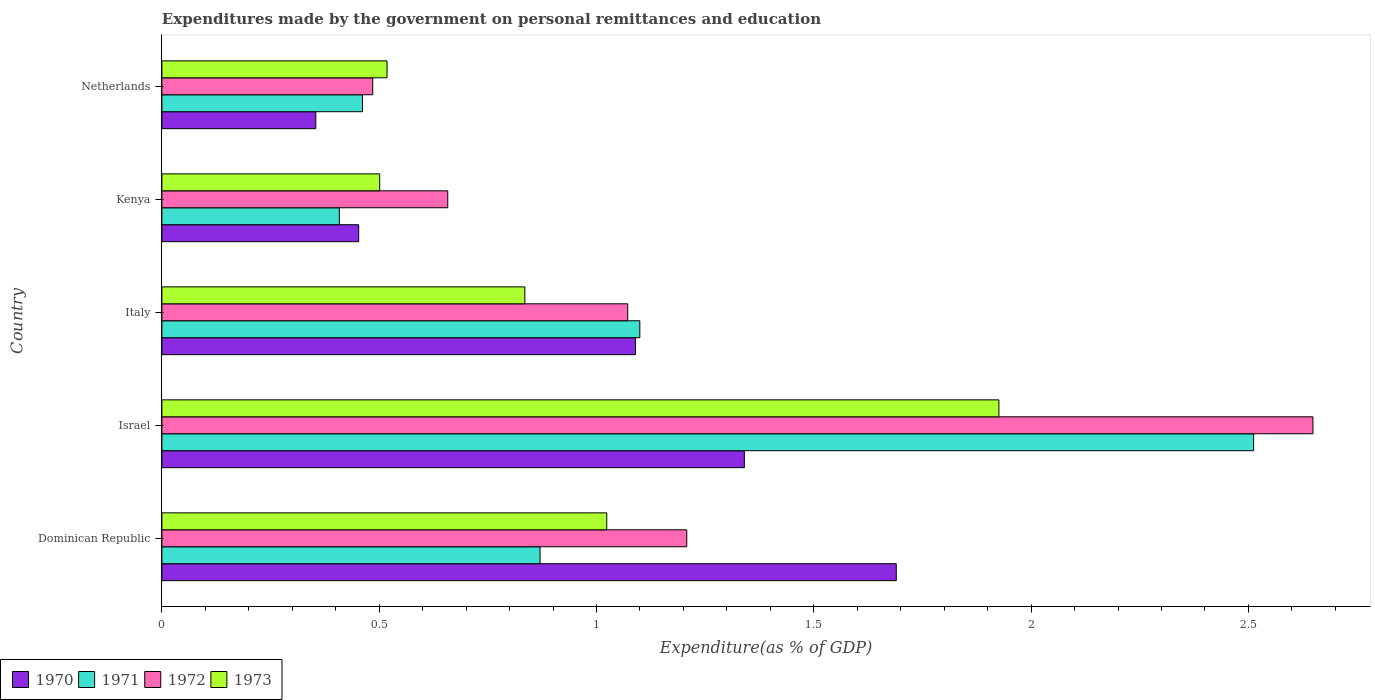How many groups of bars are there?
Give a very brief answer. 5. Are the number of bars per tick equal to the number of legend labels?
Ensure brevity in your answer.  Yes. How many bars are there on the 2nd tick from the top?
Give a very brief answer. 4. What is the label of the 5th group of bars from the top?
Ensure brevity in your answer.  Dominican Republic. What is the expenditures made by the government on personal remittances and education in 1972 in Netherlands?
Offer a very short reply. 0.49. Across all countries, what is the maximum expenditures made by the government on personal remittances and education in 1973?
Give a very brief answer. 1.93. Across all countries, what is the minimum expenditures made by the government on personal remittances and education in 1973?
Offer a very short reply. 0.5. In which country was the expenditures made by the government on personal remittances and education in 1970 maximum?
Offer a very short reply. Dominican Republic. In which country was the expenditures made by the government on personal remittances and education in 1971 minimum?
Your answer should be compact. Kenya. What is the total expenditures made by the government on personal remittances and education in 1972 in the graph?
Make the answer very short. 6.07. What is the difference between the expenditures made by the government on personal remittances and education in 1972 in Israel and that in Kenya?
Offer a terse response. 1.99. What is the difference between the expenditures made by the government on personal remittances and education in 1971 in Italy and the expenditures made by the government on personal remittances and education in 1973 in Netherlands?
Provide a short and direct response. 0.58. What is the average expenditures made by the government on personal remittances and education in 1971 per country?
Your response must be concise. 1.07. What is the difference between the expenditures made by the government on personal remittances and education in 1973 and expenditures made by the government on personal remittances and education in 1970 in Dominican Republic?
Your response must be concise. -0.67. What is the ratio of the expenditures made by the government on personal remittances and education in 1971 in Dominican Republic to that in Kenya?
Offer a terse response. 2.13. Is the difference between the expenditures made by the government on personal remittances and education in 1973 in Dominican Republic and Kenya greater than the difference between the expenditures made by the government on personal remittances and education in 1970 in Dominican Republic and Kenya?
Offer a very short reply. No. What is the difference between the highest and the second highest expenditures made by the government on personal remittances and education in 1971?
Your answer should be very brief. 1.41. What is the difference between the highest and the lowest expenditures made by the government on personal remittances and education in 1973?
Provide a succinct answer. 1.42. In how many countries, is the expenditures made by the government on personal remittances and education in 1973 greater than the average expenditures made by the government on personal remittances and education in 1973 taken over all countries?
Offer a very short reply. 2. Is it the case that in every country, the sum of the expenditures made by the government on personal remittances and education in 1970 and expenditures made by the government on personal remittances and education in 1972 is greater than the sum of expenditures made by the government on personal remittances and education in 1971 and expenditures made by the government on personal remittances and education in 1973?
Your answer should be compact. No. Is it the case that in every country, the sum of the expenditures made by the government on personal remittances and education in 1973 and expenditures made by the government on personal remittances and education in 1970 is greater than the expenditures made by the government on personal remittances and education in 1971?
Give a very brief answer. Yes. How many bars are there?
Give a very brief answer. 20. Are all the bars in the graph horizontal?
Ensure brevity in your answer.  Yes. How many countries are there in the graph?
Offer a terse response. 5. What is the difference between two consecutive major ticks on the X-axis?
Keep it short and to the point. 0.5. Does the graph contain any zero values?
Your response must be concise. No. Does the graph contain grids?
Keep it short and to the point. No. How many legend labels are there?
Ensure brevity in your answer.  4. What is the title of the graph?
Offer a terse response. Expenditures made by the government on personal remittances and education. What is the label or title of the X-axis?
Provide a short and direct response. Expenditure(as % of GDP). What is the label or title of the Y-axis?
Offer a terse response. Country. What is the Expenditure(as % of GDP) in 1970 in Dominican Republic?
Offer a very short reply. 1.69. What is the Expenditure(as % of GDP) in 1971 in Dominican Republic?
Your response must be concise. 0.87. What is the Expenditure(as % of GDP) of 1972 in Dominican Republic?
Provide a short and direct response. 1.21. What is the Expenditure(as % of GDP) in 1973 in Dominican Republic?
Offer a terse response. 1.02. What is the Expenditure(as % of GDP) of 1970 in Israel?
Offer a terse response. 1.34. What is the Expenditure(as % of GDP) of 1971 in Israel?
Make the answer very short. 2.51. What is the Expenditure(as % of GDP) of 1972 in Israel?
Give a very brief answer. 2.65. What is the Expenditure(as % of GDP) of 1973 in Israel?
Offer a very short reply. 1.93. What is the Expenditure(as % of GDP) in 1970 in Italy?
Your answer should be compact. 1.09. What is the Expenditure(as % of GDP) in 1971 in Italy?
Make the answer very short. 1.1. What is the Expenditure(as % of GDP) of 1972 in Italy?
Provide a succinct answer. 1.07. What is the Expenditure(as % of GDP) in 1973 in Italy?
Provide a succinct answer. 0.84. What is the Expenditure(as % of GDP) in 1970 in Kenya?
Provide a short and direct response. 0.45. What is the Expenditure(as % of GDP) of 1971 in Kenya?
Your response must be concise. 0.41. What is the Expenditure(as % of GDP) of 1972 in Kenya?
Keep it short and to the point. 0.66. What is the Expenditure(as % of GDP) of 1973 in Kenya?
Make the answer very short. 0.5. What is the Expenditure(as % of GDP) in 1970 in Netherlands?
Provide a short and direct response. 0.35. What is the Expenditure(as % of GDP) of 1971 in Netherlands?
Your answer should be very brief. 0.46. What is the Expenditure(as % of GDP) in 1972 in Netherlands?
Your answer should be compact. 0.49. What is the Expenditure(as % of GDP) of 1973 in Netherlands?
Provide a short and direct response. 0.52. Across all countries, what is the maximum Expenditure(as % of GDP) of 1970?
Your answer should be compact. 1.69. Across all countries, what is the maximum Expenditure(as % of GDP) of 1971?
Provide a short and direct response. 2.51. Across all countries, what is the maximum Expenditure(as % of GDP) in 1972?
Your response must be concise. 2.65. Across all countries, what is the maximum Expenditure(as % of GDP) of 1973?
Your answer should be compact. 1.93. Across all countries, what is the minimum Expenditure(as % of GDP) of 1970?
Make the answer very short. 0.35. Across all countries, what is the minimum Expenditure(as % of GDP) of 1971?
Your answer should be very brief. 0.41. Across all countries, what is the minimum Expenditure(as % of GDP) in 1972?
Make the answer very short. 0.49. Across all countries, what is the minimum Expenditure(as % of GDP) of 1973?
Offer a very short reply. 0.5. What is the total Expenditure(as % of GDP) of 1970 in the graph?
Ensure brevity in your answer.  4.93. What is the total Expenditure(as % of GDP) of 1971 in the graph?
Make the answer very short. 5.35. What is the total Expenditure(as % of GDP) in 1972 in the graph?
Your answer should be compact. 6.07. What is the total Expenditure(as % of GDP) in 1973 in the graph?
Provide a short and direct response. 4.8. What is the difference between the Expenditure(as % of GDP) in 1970 in Dominican Republic and that in Israel?
Offer a terse response. 0.35. What is the difference between the Expenditure(as % of GDP) in 1971 in Dominican Republic and that in Israel?
Ensure brevity in your answer.  -1.64. What is the difference between the Expenditure(as % of GDP) of 1972 in Dominican Republic and that in Israel?
Keep it short and to the point. -1.44. What is the difference between the Expenditure(as % of GDP) of 1973 in Dominican Republic and that in Israel?
Give a very brief answer. -0.9. What is the difference between the Expenditure(as % of GDP) of 1970 in Dominican Republic and that in Italy?
Keep it short and to the point. 0.6. What is the difference between the Expenditure(as % of GDP) of 1971 in Dominican Republic and that in Italy?
Keep it short and to the point. -0.23. What is the difference between the Expenditure(as % of GDP) of 1972 in Dominican Republic and that in Italy?
Make the answer very short. 0.14. What is the difference between the Expenditure(as % of GDP) of 1973 in Dominican Republic and that in Italy?
Offer a very short reply. 0.19. What is the difference between the Expenditure(as % of GDP) in 1970 in Dominican Republic and that in Kenya?
Keep it short and to the point. 1.24. What is the difference between the Expenditure(as % of GDP) of 1971 in Dominican Republic and that in Kenya?
Give a very brief answer. 0.46. What is the difference between the Expenditure(as % of GDP) in 1972 in Dominican Republic and that in Kenya?
Ensure brevity in your answer.  0.55. What is the difference between the Expenditure(as % of GDP) in 1973 in Dominican Republic and that in Kenya?
Give a very brief answer. 0.52. What is the difference between the Expenditure(as % of GDP) of 1970 in Dominican Republic and that in Netherlands?
Your answer should be compact. 1.34. What is the difference between the Expenditure(as % of GDP) in 1971 in Dominican Republic and that in Netherlands?
Keep it short and to the point. 0.41. What is the difference between the Expenditure(as % of GDP) of 1972 in Dominican Republic and that in Netherlands?
Keep it short and to the point. 0.72. What is the difference between the Expenditure(as % of GDP) in 1973 in Dominican Republic and that in Netherlands?
Your answer should be very brief. 0.51. What is the difference between the Expenditure(as % of GDP) of 1970 in Israel and that in Italy?
Your answer should be very brief. 0.25. What is the difference between the Expenditure(as % of GDP) in 1971 in Israel and that in Italy?
Offer a very short reply. 1.41. What is the difference between the Expenditure(as % of GDP) of 1972 in Israel and that in Italy?
Your answer should be very brief. 1.58. What is the difference between the Expenditure(as % of GDP) of 1973 in Israel and that in Italy?
Give a very brief answer. 1.09. What is the difference between the Expenditure(as % of GDP) in 1970 in Israel and that in Kenya?
Offer a very short reply. 0.89. What is the difference between the Expenditure(as % of GDP) in 1971 in Israel and that in Kenya?
Your answer should be compact. 2.1. What is the difference between the Expenditure(as % of GDP) of 1972 in Israel and that in Kenya?
Keep it short and to the point. 1.99. What is the difference between the Expenditure(as % of GDP) of 1973 in Israel and that in Kenya?
Keep it short and to the point. 1.42. What is the difference between the Expenditure(as % of GDP) of 1970 in Israel and that in Netherlands?
Provide a short and direct response. 0.99. What is the difference between the Expenditure(as % of GDP) in 1971 in Israel and that in Netherlands?
Provide a succinct answer. 2.05. What is the difference between the Expenditure(as % of GDP) of 1972 in Israel and that in Netherlands?
Your response must be concise. 2.16. What is the difference between the Expenditure(as % of GDP) of 1973 in Israel and that in Netherlands?
Make the answer very short. 1.41. What is the difference between the Expenditure(as % of GDP) in 1970 in Italy and that in Kenya?
Offer a very short reply. 0.64. What is the difference between the Expenditure(as % of GDP) in 1971 in Italy and that in Kenya?
Keep it short and to the point. 0.69. What is the difference between the Expenditure(as % of GDP) in 1972 in Italy and that in Kenya?
Ensure brevity in your answer.  0.41. What is the difference between the Expenditure(as % of GDP) in 1973 in Italy and that in Kenya?
Offer a very short reply. 0.33. What is the difference between the Expenditure(as % of GDP) of 1970 in Italy and that in Netherlands?
Offer a terse response. 0.74. What is the difference between the Expenditure(as % of GDP) in 1971 in Italy and that in Netherlands?
Provide a succinct answer. 0.64. What is the difference between the Expenditure(as % of GDP) of 1972 in Italy and that in Netherlands?
Keep it short and to the point. 0.59. What is the difference between the Expenditure(as % of GDP) in 1973 in Italy and that in Netherlands?
Offer a terse response. 0.32. What is the difference between the Expenditure(as % of GDP) of 1970 in Kenya and that in Netherlands?
Make the answer very short. 0.1. What is the difference between the Expenditure(as % of GDP) of 1971 in Kenya and that in Netherlands?
Your response must be concise. -0.05. What is the difference between the Expenditure(as % of GDP) of 1972 in Kenya and that in Netherlands?
Make the answer very short. 0.17. What is the difference between the Expenditure(as % of GDP) of 1973 in Kenya and that in Netherlands?
Ensure brevity in your answer.  -0.02. What is the difference between the Expenditure(as % of GDP) of 1970 in Dominican Republic and the Expenditure(as % of GDP) of 1971 in Israel?
Your response must be concise. -0.82. What is the difference between the Expenditure(as % of GDP) of 1970 in Dominican Republic and the Expenditure(as % of GDP) of 1972 in Israel?
Offer a very short reply. -0.96. What is the difference between the Expenditure(as % of GDP) of 1970 in Dominican Republic and the Expenditure(as % of GDP) of 1973 in Israel?
Provide a succinct answer. -0.24. What is the difference between the Expenditure(as % of GDP) of 1971 in Dominican Republic and the Expenditure(as % of GDP) of 1972 in Israel?
Provide a short and direct response. -1.78. What is the difference between the Expenditure(as % of GDP) of 1971 in Dominican Republic and the Expenditure(as % of GDP) of 1973 in Israel?
Your answer should be compact. -1.06. What is the difference between the Expenditure(as % of GDP) of 1972 in Dominican Republic and the Expenditure(as % of GDP) of 1973 in Israel?
Offer a terse response. -0.72. What is the difference between the Expenditure(as % of GDP) in 1970 in Dominican Republic and the Expenditure(as % of GDP) in 1971 in Italy?
Your answer should be compact. 0.59. What is the difference between the Expenditure(as % of GDP) of 1970 in Dominican Republic and the Expenditure(as % of GDP) of 1972 in Italy?
Make the answer very short. 0.62. What is the difference between the Expenditure(as % of GDP) of 1970 in Dominican Republic and the Expenditure(as % of GDP) of 1973 in Italy?
Offer a terse response. 0.85. What is the difference between the Expenditure(as % of GDP) in 1971 in Dominican Republic and the Expenditure(as % of GDP) in 1972 in Italy?
Provide a short and direct response. -0.2. What is the difference between the Expenditure(as % of GDP) in 1971 in Dominican Republic and the Expenditure(as % of GDP) in 1973 in Italy?
Your response must be concise. 0.04. What is the difference between the Expenditure(as % of GDP) in 1972 in Dominican Republic and the Expenditure(as % of GDP) in 1973 in Italy?
Ensure brevity in your answer.  0.37. What is the difference between the Expenditure(as % of GDP) of 1970 in Dominican Republic and the Expenditure(as % of GDP) of 1971 in Kenya?
Offer a terse response. 1.28. What is the difference between the Expenditure(as % of GDP) of 1970 in Dominican Republic and the Expenditure(as % of GDP) of 1972 in Kenya?
Make the answer very short. 1.03. What is the difference between the Expenditure(as % of GDP) of 1970 in Dominican Republic and the Expenditure(as % of GDP) of 1973 in Kenya?
Provide a short and direct response. 1.19. What is the difference between the Expenditure(as % of GDP) of 1971 in Dominican Republic and the Expenditure(as % of GDP) of 1972 in Kenya?
Make the answer very short. 0.21. What is the difference between the Expenditure(as % of GDP) of 1971 in Dominican Republic and the Expenditure(as % of GDP) of 1973 in Kenya?
Provide a short and direct response. 0.37. What is the difference between the Expenditure(as % of GDP) of 1972 in Dominican Republic and the Expenditure(as % of GDP) of 1973 in Kenya?
Provide a short and direct response. 0.71. What is the difference between the Expenditure(as % of GDP) in 1970 in Dominican Republic and the Expenditure(as % of GDP) in 1971 in Netherlands?
Provide a succinct answer. 1.23. What is the difference between the Expenditure(as % of GDP) in 1970 in Dominican Republic and the Expenditure(as % of GDP) in 1972 in Netherlands?
Make the answer very short. 1.2. What is the difference between the Expenditure(as % of GDP) in 1970 in Dominican Republic and the Expenditure(as % of GDP) in 1973 in Netherlands?
Your answer should be compact. 1.17. What is the difference between the Expenditure(as % of GDP) in 1971 in Dominican Republic and the Expenditure(as % of GDP) in 1972 in Netherlands?
Make the answer very short. 0.39. What is the difference between the Expenditure(as % of GDP) of 1971 in Dominican Republic and the Expenditure(as % of GDP) of 1973 in Netherlands?
Your answer should be very brief. 0.35. What is the difference between the Expenditure(as % of GDP) of 1972 in Dominican Republic and the Expenditure(as % of GDP) of 1973 in Netherlands?
Your response must be concise. 0.69. What is the difference between the Expenditure(as % of GDP) in 1970 in Israel and the Expenditure(as % of GDP) in 1971 in Italy?
Your answer should be compact. 0.24. What is the difference between the Expenditure(as % of GDP) of 1970 in Israel and the Expenditure(as % of GDP) of 1972 in Italy?
Ensure brevity in your answer.  0.27. What is the difference between the Expenditure(as % of GDP) of 1970 in Israel and the Expenditure(as % of GDP) of 1973 in Italy?
Offer a terse response. 0.51. What is the difference between the Expenditure(as % of GDP) in 1971 in Israel and the Expenditure(as % of GDP) in 1972 in Italy?
Your answer should be compact. 1.44. What is the difference between the Expenditure(as % of GDP) of 1971 in Israel and the Expenditure(as % of GDP) of 1973 in Italy?
Make the answer very short. 1.68. What is the difference between the Expenditure(as % of GDP) in 1972 in Israel and the Expenditure(as % of GDP) in 1973 in Italy?
Your answer should be compact. 1.81. What is the difference between the Expenditure(as % of GDP) of 1970 in Israel and the Expenditure(as % of GDP) of 1971 in Kenya?
Make the answer very short. 0.93. What is the difference between the Expenditure(as % of GDP) in 1970 in Israel and the Expenditure(as % of GDP) in 1972 in Kenya?
Offer a terse response. 0.68. What is the difference between the Expenditure(as % of GDP) in 1970 in Israel and the Expenditure(as % of GDP) in 1973 in Kenya?
Your answer should be compact. 0.84. What is the difference between the Expenditure(as % of GDP) of 1971 in Israel and the Expenditure(as % of GDP) of 1972 in Kenya?
Your answer should be very brief. 1.85. What is the difference between the Expenditure(as % of GDP) in 1971 in Israel and the Expenditure(as % of GDP) in 1973 in Kenya?
Your response must be concise. 2.01. What is the difference between the Expenditure(as % of GDP) of 1972 in Israel and the Expenditure(as % of GDP) of 1973 in Kenya?
Your answer should be compact. 2.15. What is the difference between the Expenditure(as % of GDP) of 1970 in Israel and the Expenditure(as % of GDP) of 1971 in Netherlands?
Ensure brevity in your answer.  0.88. What is the difference between the Expenditure(as % of GDP) in 1970 in Israel and the Expenditure(as % of GDP) in 1972 in Netherlands?
Your answer should be compact. 0.85. What is the difference between the Expenditure(as % of GDP) in 1970 in Israel and the Expenditure(as % of GDP) in 1973 in Netherlands?
Ensure brevity in your answer.  0.82. What is the difference between the Expenditure(as % of GDP) of 1971 in Israel and the Expenditure(as % of GDP) of 1972 in Netherlands?
Ensure brevity in your answer.  2.03. What is the difference between the Expenditure(as % of GDP) in 1971 in Israel and the Expenditure(as % of GDP) in 1973 in Netherlands?
Make the answer very short. 1.99. What is the difference between the Expenditure(as % of GDP) in 1972 in Israel and the Expenditure(as % of GDP) in 1973 in Netherlands?
Your answer should be very brief. 2.13. What is the difference between the Expenditure(as % of GDP) of 1970 in Italy and the Expenditure(as % of GDP) of 1971 in Kenya?
Offer a terse response. 0.68. What is the difference between the Expenditure(as % of GDP) of 1970 in Italy and the Expenditure(as % of GDP) of 1972 in Kenya?
Offer a terse response. 0.43. What is the difference between the Expenditure(as % of GDP) of 1970 in Italy and the Expenditure(as % of GDP) of 1973 in Kenya?
Provide a short and direct response. 0.59. What is the difference between the Expenditure(as % of GDP) of 1971 in Italy and the Expenditure(as % of GDP) of 1972 in Kenya?
Offer a very short reply. 0.44. What is the difference between the Expenditure(as % of GDP) of 1971 in Italy and the Expenditure(as % of GDP) of 1973 in Kenya?
Provide a succinct answer. 0.6. What is the difference between the Expenditure(as % of GDP) of 1972 in Italy and the Expenditure(as % of GDP) of 1973 in Kenya?
Offer a terse response. 0.57. What is the difference between the Expenditure(as % of GDP) of 1970 in Italy and the Expenditure(as % of GDP) of 1971 in Netherlands?
Provide a succinct answer. 0.63. What is the difference between the Expenditure(as % of GDP) of 1970 in Italy and the Expenditure(as % of GDP) of 1972 in Netherlands?
Make the answer very short. 0.6. What is the difference between the Expenditure(as % of GDP) in 1970 in Italy and the Expenditure(as % of GDP) in 1973 in Netherlands?
Your response must be concise. 0.57. What is the difference between the Expenditure(as % of GDP) of 1971 in Italy and the Expenditure(as % of GDP) of 1972 in Netherlands?
Provide a short and direct response. 0.61. What is the difference between the Expenditure(as % of GDP) of 1971 in Italy and the Expenditure(as % of GDP) of 1973 in Netherlands?
Make the answer very short. 0.58. What is the difference between the Expenditure(as % of GDP) in 1972 in Italy and the Expenditure(as % of GDP) in 1973 in Netherlands?
Provide a short and direct response. 0.55. What is the difference between the Expenditure(as % of GDP) of 1970 in Kenya and the Expenditure(as % of GDP) of 1971 in Netherlands?
Offer a very short reply. -0.01. What is the difference between the Expenditure(as % of GDP) of 1970 in Kenya and the Expenditure(as % of GDP) of 1972 in Netherlands?
Provide a succinct answer. -0.03. What is the difference between the Expenditure(as % of GDP) of 1970 in Kenya and the Expenditure(as % of GDP) of 1973 in Netherlands?
Your answer should be compact. -0.07. What is the difference between the Expenditure(as % of GDP) of 1971 in Kenya and the Expenditure(as % of GDP) of 1972 in Netherlands?
Offer a very short reply. -0.08. What is the difference between the Expenditure(as % of GDP) in 1971 in Kenya and the Expenditure(as % of GDP) in 1973 in Netherlands?
Your answer should be compact. -0.11. What is the difference between the Expenditure(as % of GDP) of 1972 in Kenya and the Expenditure(as % of GDP) of 1973 in Netherlands?
Give a very brief answer. 0.14. What is the average Expenditure(as % of GDP) of 1970 per country?
Your response must be concise. 0.99. What is the average Expenditure(as % of GDP) in 1971 per country?
Keep it short and to the point. 1.07. What is the average Expenditure(as % of GDP) of 1972 per country?
Provide a short and direct response. 1.21. What is the average Expenditure(as % of GDP) in 1973 per country?
Ensure brevity in your answer.  0.96. What is the difference between the Expenditure(as % of GDP) in 1970 and Expenditure(as % of GDP) in 1971 in Dominican Republic?
Your response must be concise. 0.82. What is the difference between the Expenditure(as % of GDP) in 1970 and Expenditure(as % of GDP) in 1972 in Dominican Republic?
Give a very brief answer. 0.48. What is the difference between the Expenditure(as % of GDP) of 1970 and Expenditure(as % of GDP) of 1973 in Dominican Republic?
Make the answer very short. 0.67. What is the difference between the Expenditure(as % of GDP) in 1971 and Expenditure(as % of GDP) in 1972 in Dominican Republic?
Your answer should be very brief. -0.34. What is the difference between the Expenditure(as % of GDP) of 1971 and Expenditure(as % of GDP) of 1973 in Dominican Republic?
Keep it short and to the point. -0.15. What is the difference between the Expenditure(as % of GDP) of 1972 and Expenditure(as % of GDP) of 1973 in Dominican Republic?
Provide a short and direct response. 0.18. What is the difference between the Expenditure(as % of GDP) in 1970 and Expenditure(as % of GDP) in 1971 in Israel?
Keep it short and to the point. -1.17. What is the difference between the Expenditure(as % of GDP) of 1970 and Expenditure(as % of GDP) of 1972 in Israel?
Your response must be concise. -1.31. What is the difference between the Expenditure(as % of GDP) in 1970 and Expenditure(as % of GDP) in 1973 in Israel?
Ensure brevity in your answer.  -0.59. What is the difference between the Expenditure(as % of GDP) of 1971 and Expenditure(as % of GDP) of 1972 in Israel?
Make the answer very short. -0.14. What is the difference between the Expenditure(as % of GDP) in 1971 and Expenditure(as % of GDP) in 1973 in Israel?
Give a very brief answer. 0.59. What is the difference between the Expenditure(as % of GDP) of 1972 and Expenditure(as % of GDP) of 1973 in Israel?
Give a very brief answer. 0.72. What is the difference between the Expenditure(as % of GDP) in 1970 and Expenditure(as % of GDP) in 1971 in Italy?
Offer a terse response. -0.01. What is the difference between the Expenditure(as % of GDP) of 1970 and Expenditure(as % of GDP) of 1972 in Italy?
Give a very brief answer. 0.02. What is the difference between the Expenditure(as % of GDP) in 1970 and Expenditure(as % of GDP) in 1973 in Italy?
Give a very brief answer. 0.25. What is the difference between the Expenditure(as % of GDP) of 1971 and Expenditure(as % of GDP) of 1972 in Italy?
Offer a terse response. 0.03. What is the difference between the Expenditure(as % of GDP) of 1971 and Expenditure(as % of GDP) of 1973 in Italy?
Your answer should be very brief. 0.26. What is the difference between the Expenditure(as % of GDP) of 1972 and Expenditure(as % of GDP) of 1973 in Italy?
Your response must be concise. 0.24. What is the difference between the Expenditure(as % of GDP) of 1970 and Expenditure(as % of GDP) of 1971 in Kenya?
Offer a terse response. 0.04. What is the difference between the Expenditure(as % of GDP) in 1970 and Expenditure(as % of GDP) in 1972 in Kenya?
Provide a short and direct response. -0.2. What is the difference between the Expenditure(as % of GDP) in 1970 and Expenditure(as % of GDP) in 1973 in Kenya?
Offer a very short reply. -0.05. What is the difference between the Expenditure(as % of GDP) of 1971 and Expenditure(as % of GDP) of 1972 in Kenya?
Your answer should be compact. -0.25. What is the difference between the Expenditure(as % of GDP) in 1971 and Expenditure(as % of GDP) in 1973 in Kenya?
Provide a short and direct response. -0.09. What is the difference between the Expenditure(as % of GDP) in 1972 and Expenditure(as % of GDP) in 1973 in Kenya?
Your answer should be compact. 0.16. What is the difference between the Expenditure(as % of GDP) in 1970 and Expenditure(as % of GDP) in 1971 in Netherlands?
Your answer should be very brief. -0.11. What is the difference between the Expenditure(as % of GDP) in 1970 and Expenditure(as % of GDP) in 1972 in Netherlands?
Offer a terse response. -0.13. What is the difference between the Expenditure(as % of GDP) in 1970 and Expenditure(as % of GDP) in 1973 in Netherlands?
Your response must be concise. -0.16. What is the difference between the Expenditure(as % of GDP) of 1971 and Expenditure(as % of GDP) of 1972 in Netherlands?
Provide a short and direct response. -0.02. What is the difference between the Expenditure(as % of GDP) of 1971 and Expenditure(as % of GDP) of 1973 in Netherlands?
Your answer should be compact. -0.06. What is the difference between the Expenditure(as % of GDP) in 1972 and Expenditure(as % of GDP) in 1973 in Netherlands?
Your answer should be very brief. -0.03. What is the ratio of the Expenditure(as % of GDP) of 1970 in Dominican Republic to that in Israel?
Ensure brevity in your answer.  1.26. What is the ratio of the Expenditure(as % of GDP) in 1971 in Dominican Republic to that in Israel?
Your answer should be compact. 0.35. What is the ratio of the Expenditure(as % of GDP) in 1972 in Dominican Republic to that in Israel?
Provide a short and direct response. 0.46. What is the ratio of the Expenditure(as % of GDP) in 1973 in Dominican Republic to that in Israel?
Offer a terse response. 0.53. What is the ratio of the Expenditure(as % of GDP) of 1970 in Dominican Republic to that in Italy?
Make the answer very short. 1.55. What is the ratio of the Expenditure(as % of GDP) of 1971 in Dominican Republic to that in Italy?
Your answer should be compact. 0.79. What is the ratio of the Expenditure(as % of GDP) in 1972 in Dominican Republic to that in Italy?
Offer a terse response. 1.13. What is the ratio of the Expenditure(as % of GDP) in 1973 in Dominican Republic to that in Italy?
Ensure brevity in your answer.  1.23. What is the ratio of the Expenditure(as % of GDP) of 1970 in Dominican Republic to that in Kenya?
Provide a short and direct response. 3.73. What is the ratio of the Expenditure(as % of GDP) of 1971 in Dominican Republic to that in Kenya?
Provide a short and direct response. 2.13. What is the ratio of the Expenditure(as % of GDP) in 1972 in Dominican Republic to that in Kenya?
Provide a succinct answer. 1.84. What is the ratio of the Expenditure(as % of GDP) in 1973 in Dominican Republic to that in Kenya?
Give a very brief answer. 2.04. What is the ratio of the Expenditure(as % of GDP) of 1970 in Dominican Republic to that in Netherlands?
Provide a short and direct response. 4.77. What is the ratio of the Expenditure(as % of GDP) of 1971 in Dominican Republic to that in Netherlands?
Your answer should be compact. 1.89. What is the ratio of the Expenditure(as % of GDP) of 1972 in Dominican Republic to that in Netherlands?
Provide a short and direct response. 2.49. What is the ratio of the Expenditure(as % of GDP) of 1973 in Dominican Republic to that in Netherlands?
Provide a short and direct response. 1.98. What is the ratio of the Expenditure(as % of GDP) of 1970 in Israel to that in Italy?
Give a very brief answer. 1.23. What is the ratio of the Expenditure(as % of GDP) in 1971 in Israel to that in Italy?
Provide a short and direct response. 2.28. What is the ratio of the Expenditure(as % of GDP) of 1972 in Israel to that in Italy?
Your response must be concise. 2.47. What is the ratio of the Expenditure(as % of GDP) of 1973 in Israel to that in Italy?
Give a very brief answer. 2.31. What is the ratio of the Expenditure(as % of GDP) in 1970 in Israel to that in Kenya?
Your answer should be very brief. 2.96. What is the ratio of the Expenditure(as % of GDP) of 1971 in Israel to that in Kenya?
Ensure brevity in your answer.  6.15. What is the ratio of the Expenditure(as % of GDP) in 1972 in Israel to that in Kenya?
Provide a succinct answer. 4.03. What is the ratio of the Expenditure(as % of GDP) in 1973 in Israel to that in Kenya?
Offer a terse response. 3.84. What is the ratio of the Expenditure(as % of GDP) of 1970 in Israel to that in Netherlands?
Your answer should be very brief. 3.78. What is the ratio of the Expenditure(as % of GDP) in 1971 in Israel to that in Netherlands?
Ensure brevity in your answer.  5.44. What is the ratio of the Expenditure(as % of GDP) in 1972 in Israel to that in Netherlands?
Your answer should be compact. 5.46. What is the ratio of the Expenditure(as % of GDP) in 1973 in Israel to that in Netherlands?
Offer a terse response. 3.72. What is the ratio of the Expenditure(as % of GDP) in 1970 in Italy to that in Kenya?
Keep it short and to the point. 2.41. What is the ratio of the Expenditure(as % of GDP) of 1971 in Italy to that in Kenya?
Provide a short and direct response. 2.69. What is the ratio of the Expenditure(as % of GDP) in 1972 in Italy to that in Kenya?
Your answer should be very brief. 1.63. What is the ratio of the Expenditure(as % of GDP) in 1973 in Italy to that in Kenya?
Your answer should be compact. 1.67. What is the ratio of the Expenditure(as % of GDP) in 1970 in Italy to that in Netherlands?
Provide a succinct answer. 3.08. What is the ratio of the Expenditure(as % of GDP) of 1971 in Italy to that in Netherlands?
Provide a short and direct response. 2.38. What is the ratio of the Expenditure(as % of GDP) in 1972 in Italy to that in Netherlands?
Offer a very short reply. 2.21. What is the ratio of the Expenditure(as % of GDP) of 1973 in Italy to that in Netherlands?
Your response must be concise. 1.61. What is the ratio of the Expenditure(as % of GDP) of 1970 in Kenya to that in Netherlands?
Your answer should be very brief. 1.28. What is the ratio of the Expenditure(as % of GDP) in 1971 in Kenya to that in Netherlands?
Provide a short and direct response. 0.88. What is the ratio of the Expenditure(as % of GDP) of 1972 in Kenya to that in Netherlands?
Provide a succinct answer. 1.36. What is the ratio of the Expenditure(as % of GDP) in 1973 in Kenya to that in Netherlands?
Ensure brevity in your answer.  0.97. What is the difference between the highest and the second highest Expenditure(as % of GDP) of 1970?
Your answer should be compact. 0.35. What is the difference between the highest and the second highest Expenditure(as % of GDP) of 1971?
Keep it short and to the point. 1.41. What is the difference between the highest and the second highest Expenditure(as % of GDP) of 1972?
Your answer should be compact. 1.44. What is the difference between the highest and the second highest Expenditure(as % of GDP) in 1973?
Give a very brief answer. 0.9. What is the difference between the highest and the lowest Expenditure(as % of GDP) in 1970?
Ensure brevity in your answer.  1.34. What is the difference between the highest and the lowest Expenditure(as % of GDP) of 1971?
Keep it short and to the point. 2.1. What is the difference between the highest and the lowest Expenditure(as % of GDP) of 1972?
Give a very brief answer. 2.16. What is the difference between the highest and the lowest Expenditure(as % of GDP) in 1973?
Provide a short and direct response. 1.42. 